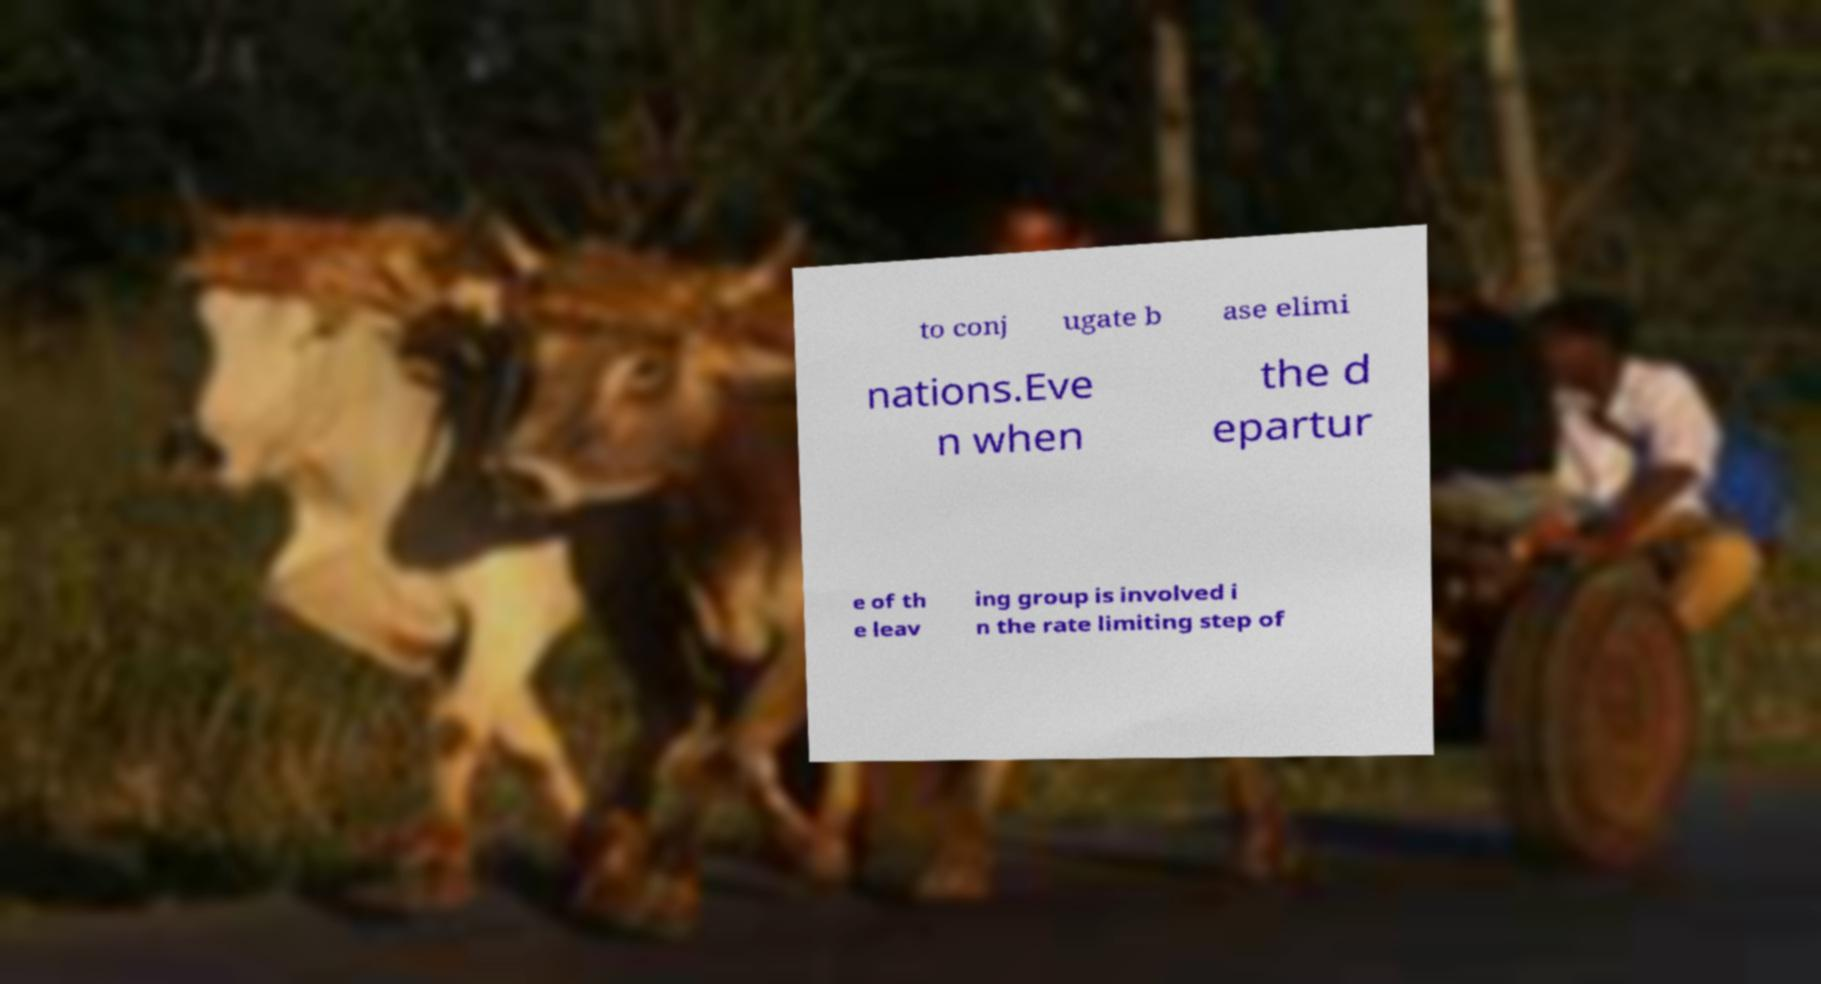Please read and relay the text visible in this image. What does it say? to conj ugate b ase elimi nations.Eve n when the d epartur e of th e leav ing group is involved i n the rate limiting step of 